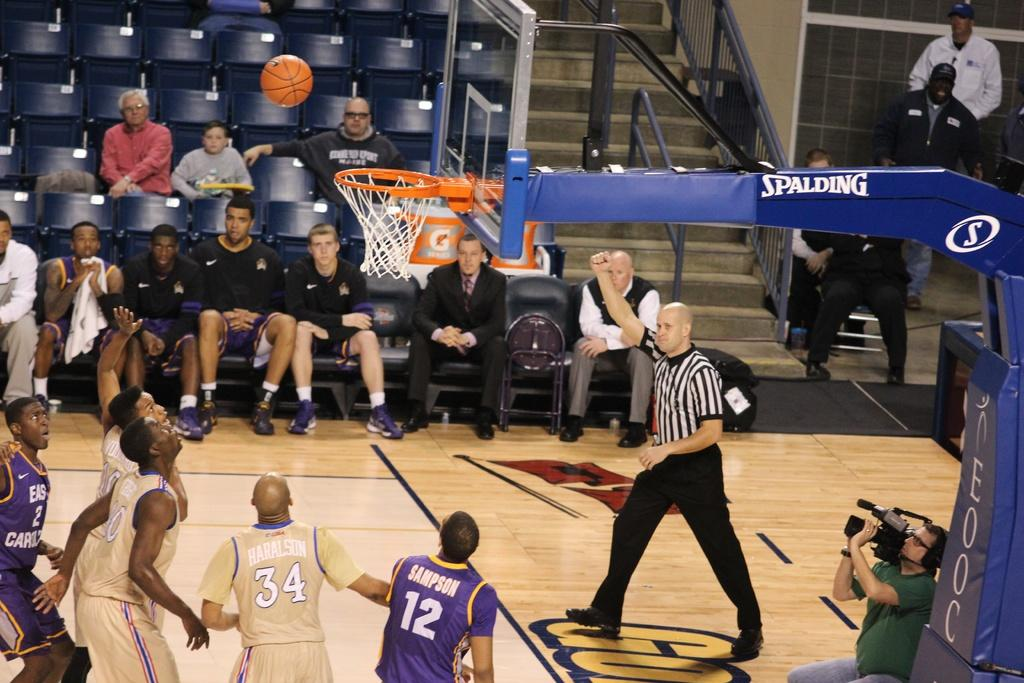<image>
Provide a brief description of the given image. A basket ball game is being played in front of a few spectators and with hoops built by a company called Spalding. 